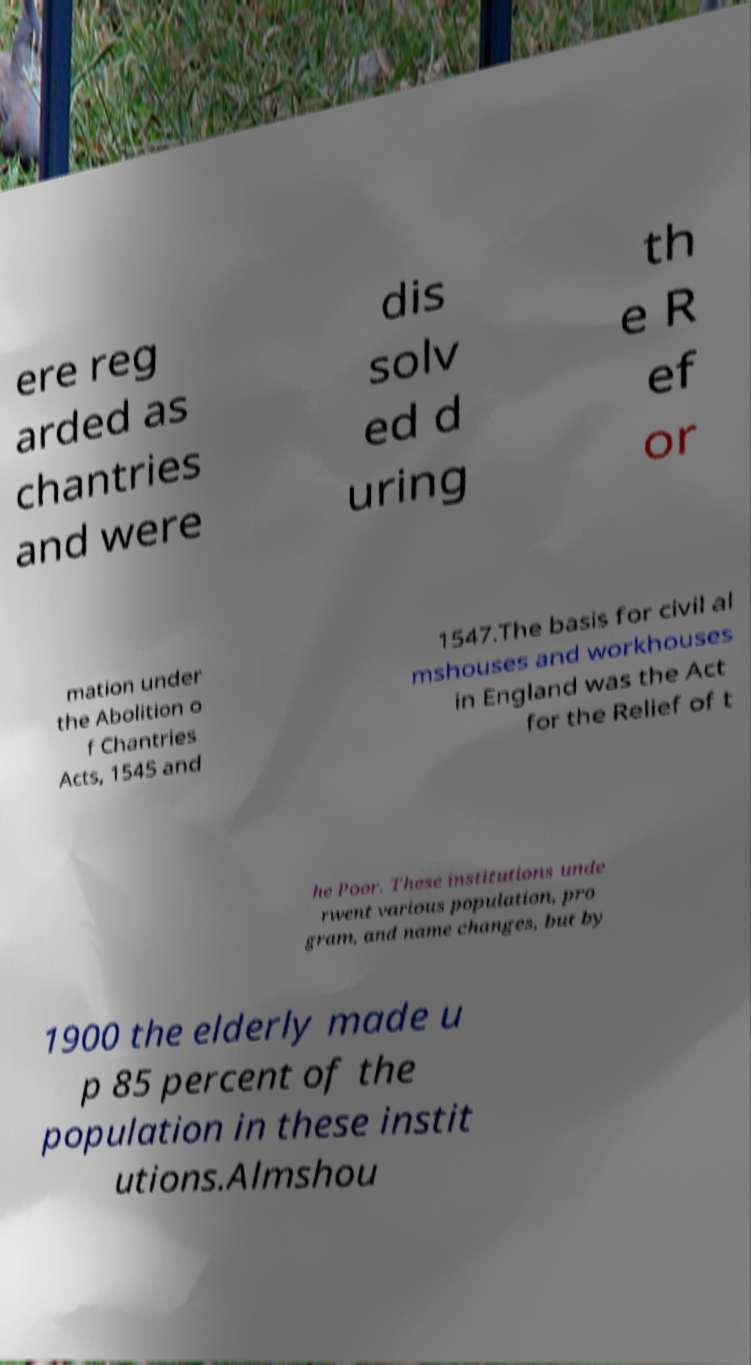Could you extract and type out the text from this image? ere reg arded as chantries and were dis solv ed d uring th e R ef or mation under the Abolition o f Chantries Acts, 1545 and 1547.The basis for civil al mshouses and workhouses in England was the Act for the Relief of t he Poor. These institutions unde rwent various population, pro gram, and name changes, but by 1900 the elderly made u p 85 percent of the population in these instit utions.Almshou 